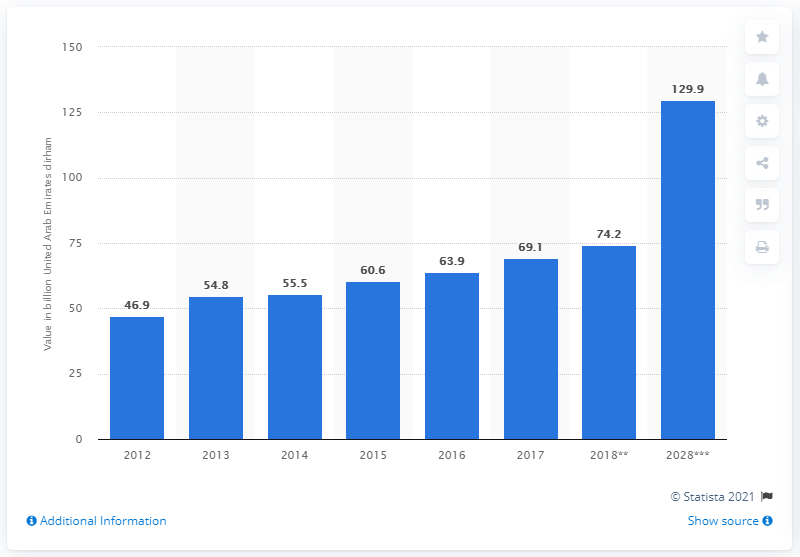Identify some key points in this picture. According to estimates, the direct contribution of tourism to the GDP of the UAE is projected to reach 129.9 by 2028. 